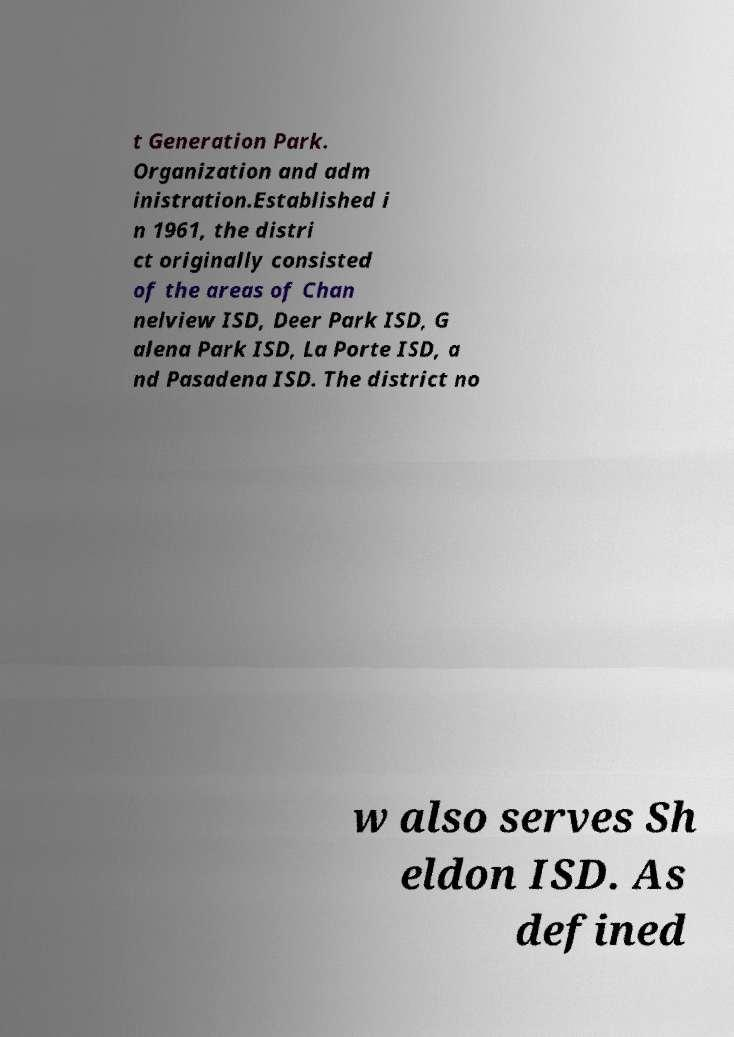There's text embedded in this image that I need extracted. Can you transcribe it verbatim? t Generation Park. Organization and adm inistration.Established i n 1961, the distri ct originally consisted of the areas of Chan nelview ISD, Deer Park ISD, G alena Park ISD, La Porte ISD, a nd Pasadena ISD. The district no w also serves Sh eldon ISD. As defined 